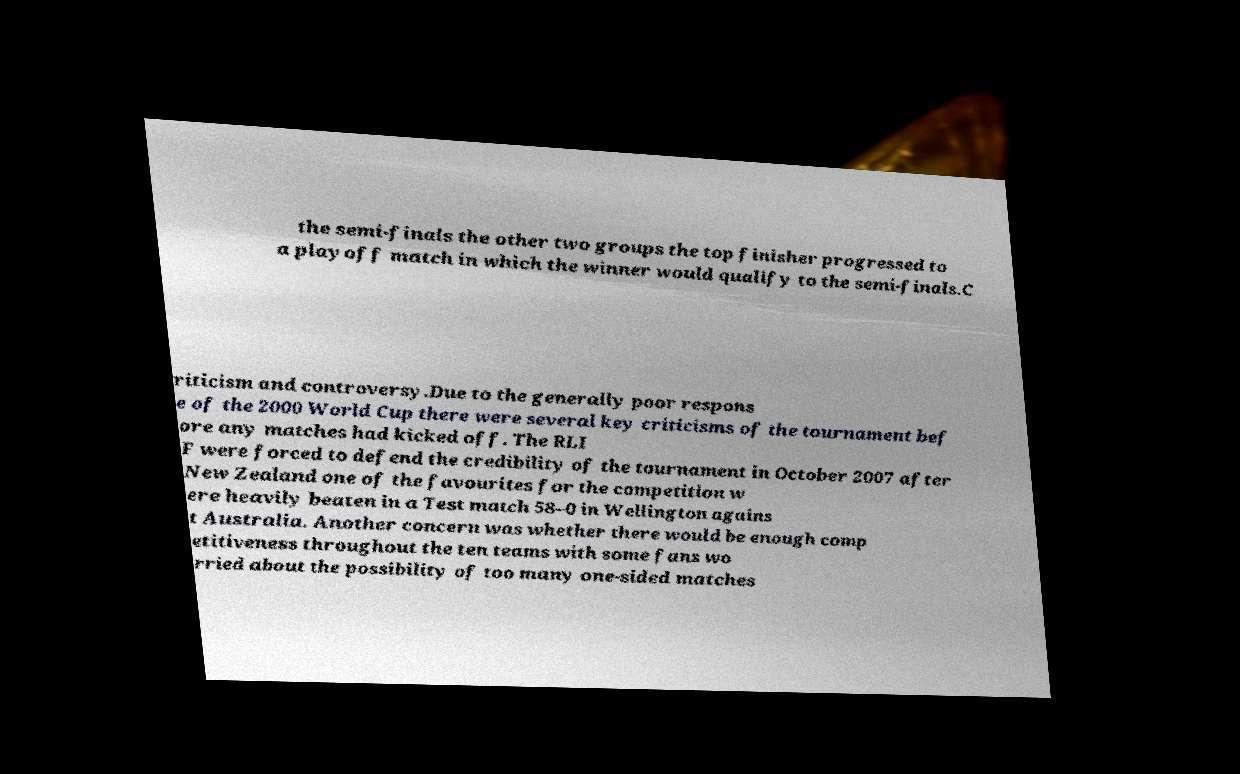Could you assist in decoding the text presented in this image and type it out clearly? the semi-finals the other two groups the top finisher progressed to a playoff match in which the winner would qualify to the semi-finals.C riticism and controversy.Due to the generally poor respons e of the 2000 World Cup there were several key criticisms of the tournament bef ore any matches had kicked off. The RLI F were forced to defend the credibility of the tournament in October 2007 after New Zealand one of the favourites for the competition w ere heavily beaten in a Test match 58–0 in Wellington agains t Australia. Another concern was whether there would be enough comp etitiveness throughout the ten teams with some fans wo rried about the possibility of too many one-sided matches 